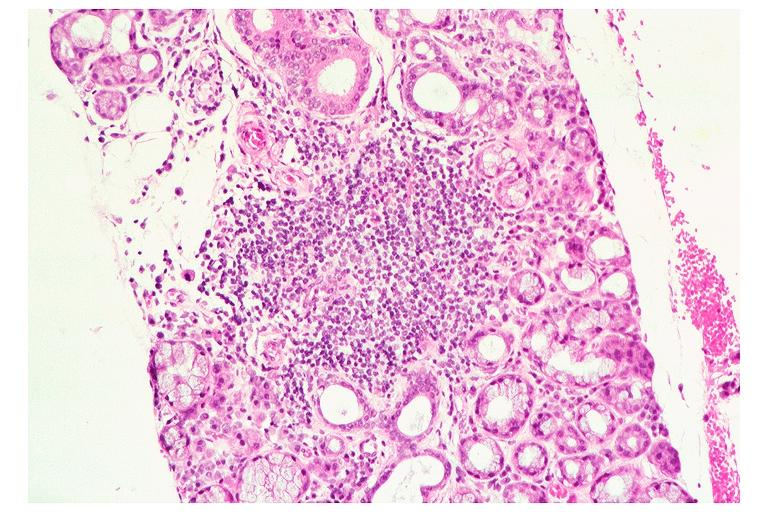what does this image show?
Answer the question using a single word or phrase. Sjogrens syndrome 